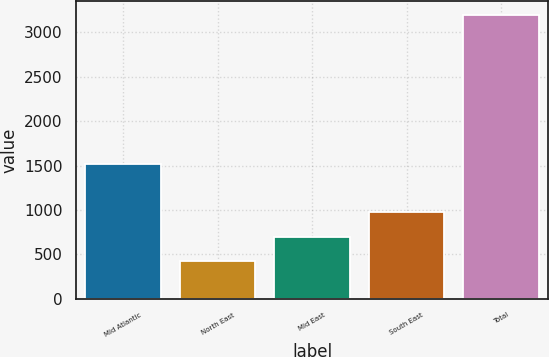<chart> <loc_0><loc_0><loc_500><loc_500><bar_chart><fcel>Mid Atlantic<fcel>North East<fcel>Mid East<fcel>South East<fcel>Total<nl><fcel>1520<fcel>420<fcel>697.4<fcel>974.8<fcel>3194<nl></chart> 